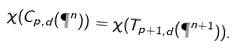Convert formula to latex. <formula><loc_0><loc_0><loc_500><loc_500>\chi ( C _ { p , d } ( \P ^ { n } ) ) = \chi ( T _ { p + 1 , d } ( \P ^ { n + 1 } ) ) .</formula> 